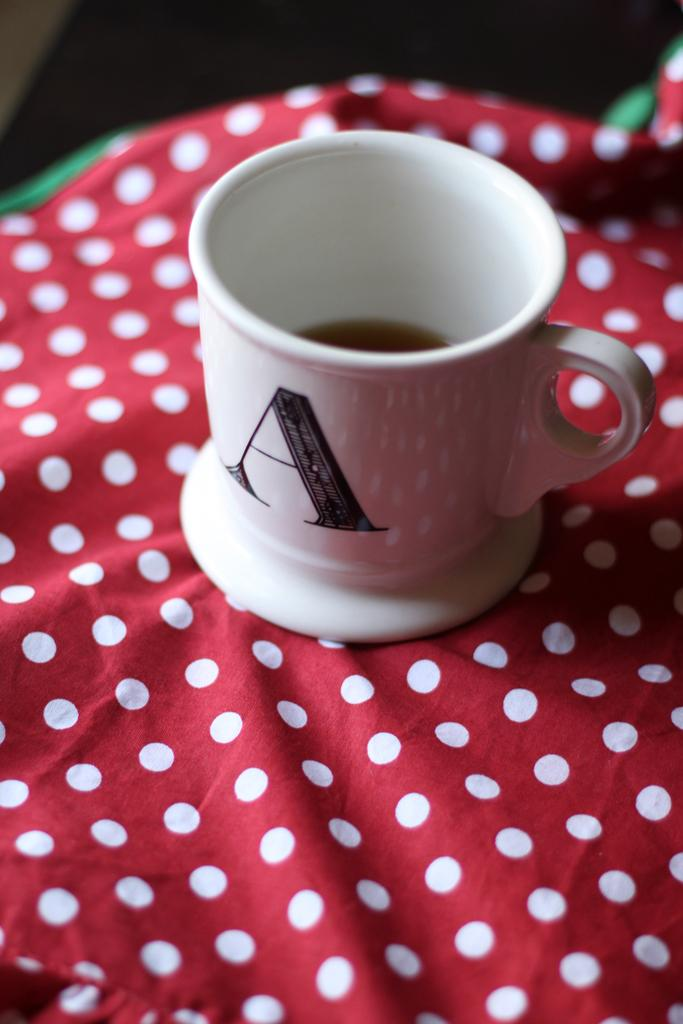<image>
Summarize the visual content of the image. A coffee mug with the initial A that sits on a table with a polka dot tablecloth. 